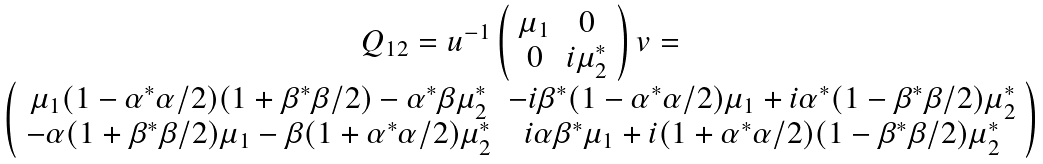<formula> <loc_0><loc_0><loc_500><loc_500>\begin{array} { c } Q _ { 1 2 } = u ^ { - 1 } \left ( \begin{array} { c c } \mu _ { 1 } & 0 \\ 0 & i \mu _ { 2 } ^ { * } \end{array} \right ) v = \\ \left ( \begin{array} { c c } \mu _ { 1 } ( 1 - \alpha ^ { * } \alpha / 2 ) ( 1 + \beta ^ { * } \beta / 2 ) - \alpha ^ { * } \beta \mu _ { 2 } ^ { * } & - i \beta ^ { * } ( 1 - \alpha ^ { * } \alpha / 2 ) \mu _ { 1 } + i \alpha ^ { * } ( 1 - \beta ^ { * } \beta / 2 ) \mu _ { 2 } ^ { * } \\ - \alpha ( 1 + \beta ^ { * } \beta / 2 ) \mu _ { 1 } - \beta ( 1 + \alpha ^ { * } \alpha / 2 ) \mu _ { 2 } ^ { * } & i \alpha \beta ^ { * } \mu _ { 1 } + i ( 1 + \alpha ^ { * } \alpha / 2 ) ( 1 - \beta ^ { * } \beta / 2 ) \mu _ { 2 } ^ { * } \end{array} \right ) \end{array}</formula> 